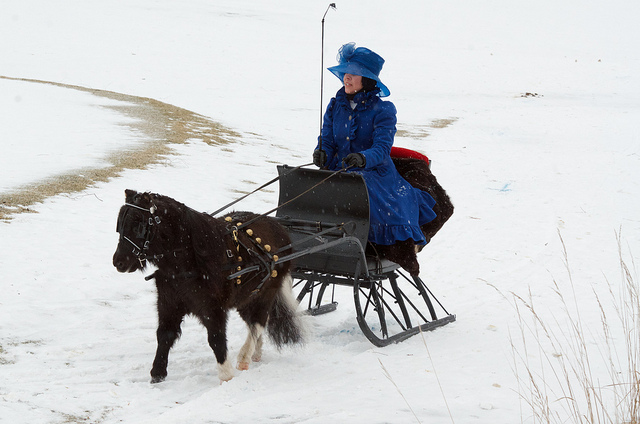What might be the occasion for the sled ride? Given the traditional and elaborate attire of the rider, the sled ride could be part of a cultural or historical reenactment, or a special festive event like a Christmas market or winter parade. 